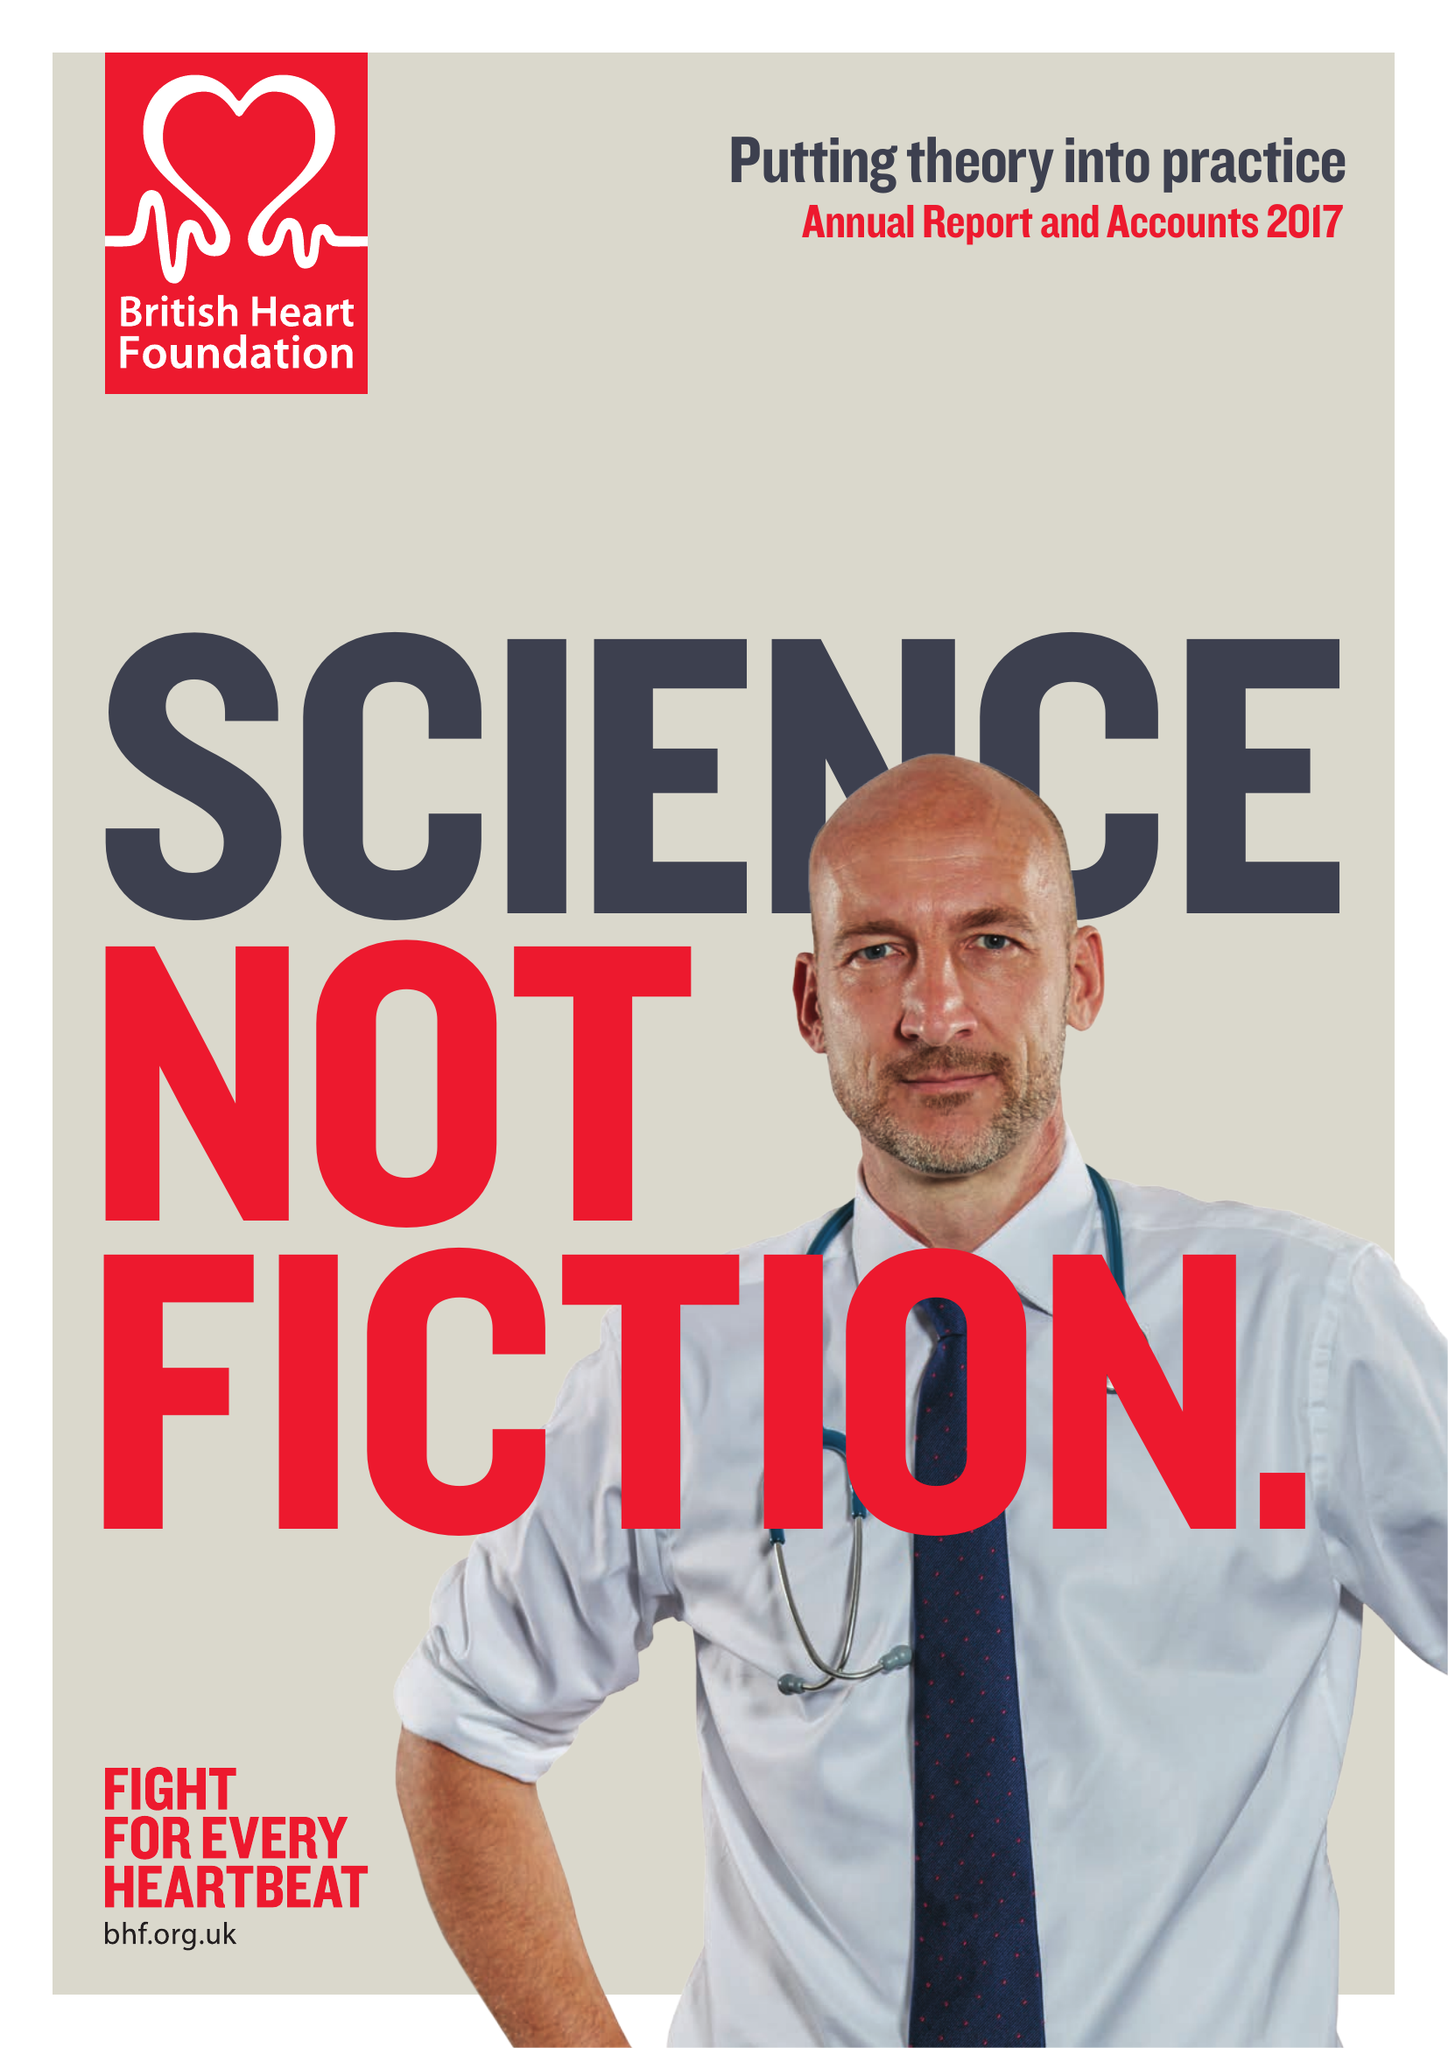What is the value for the address__street_line?
Answer the question using a single word or phrase. 180 HAMPSTEAD ROAD 